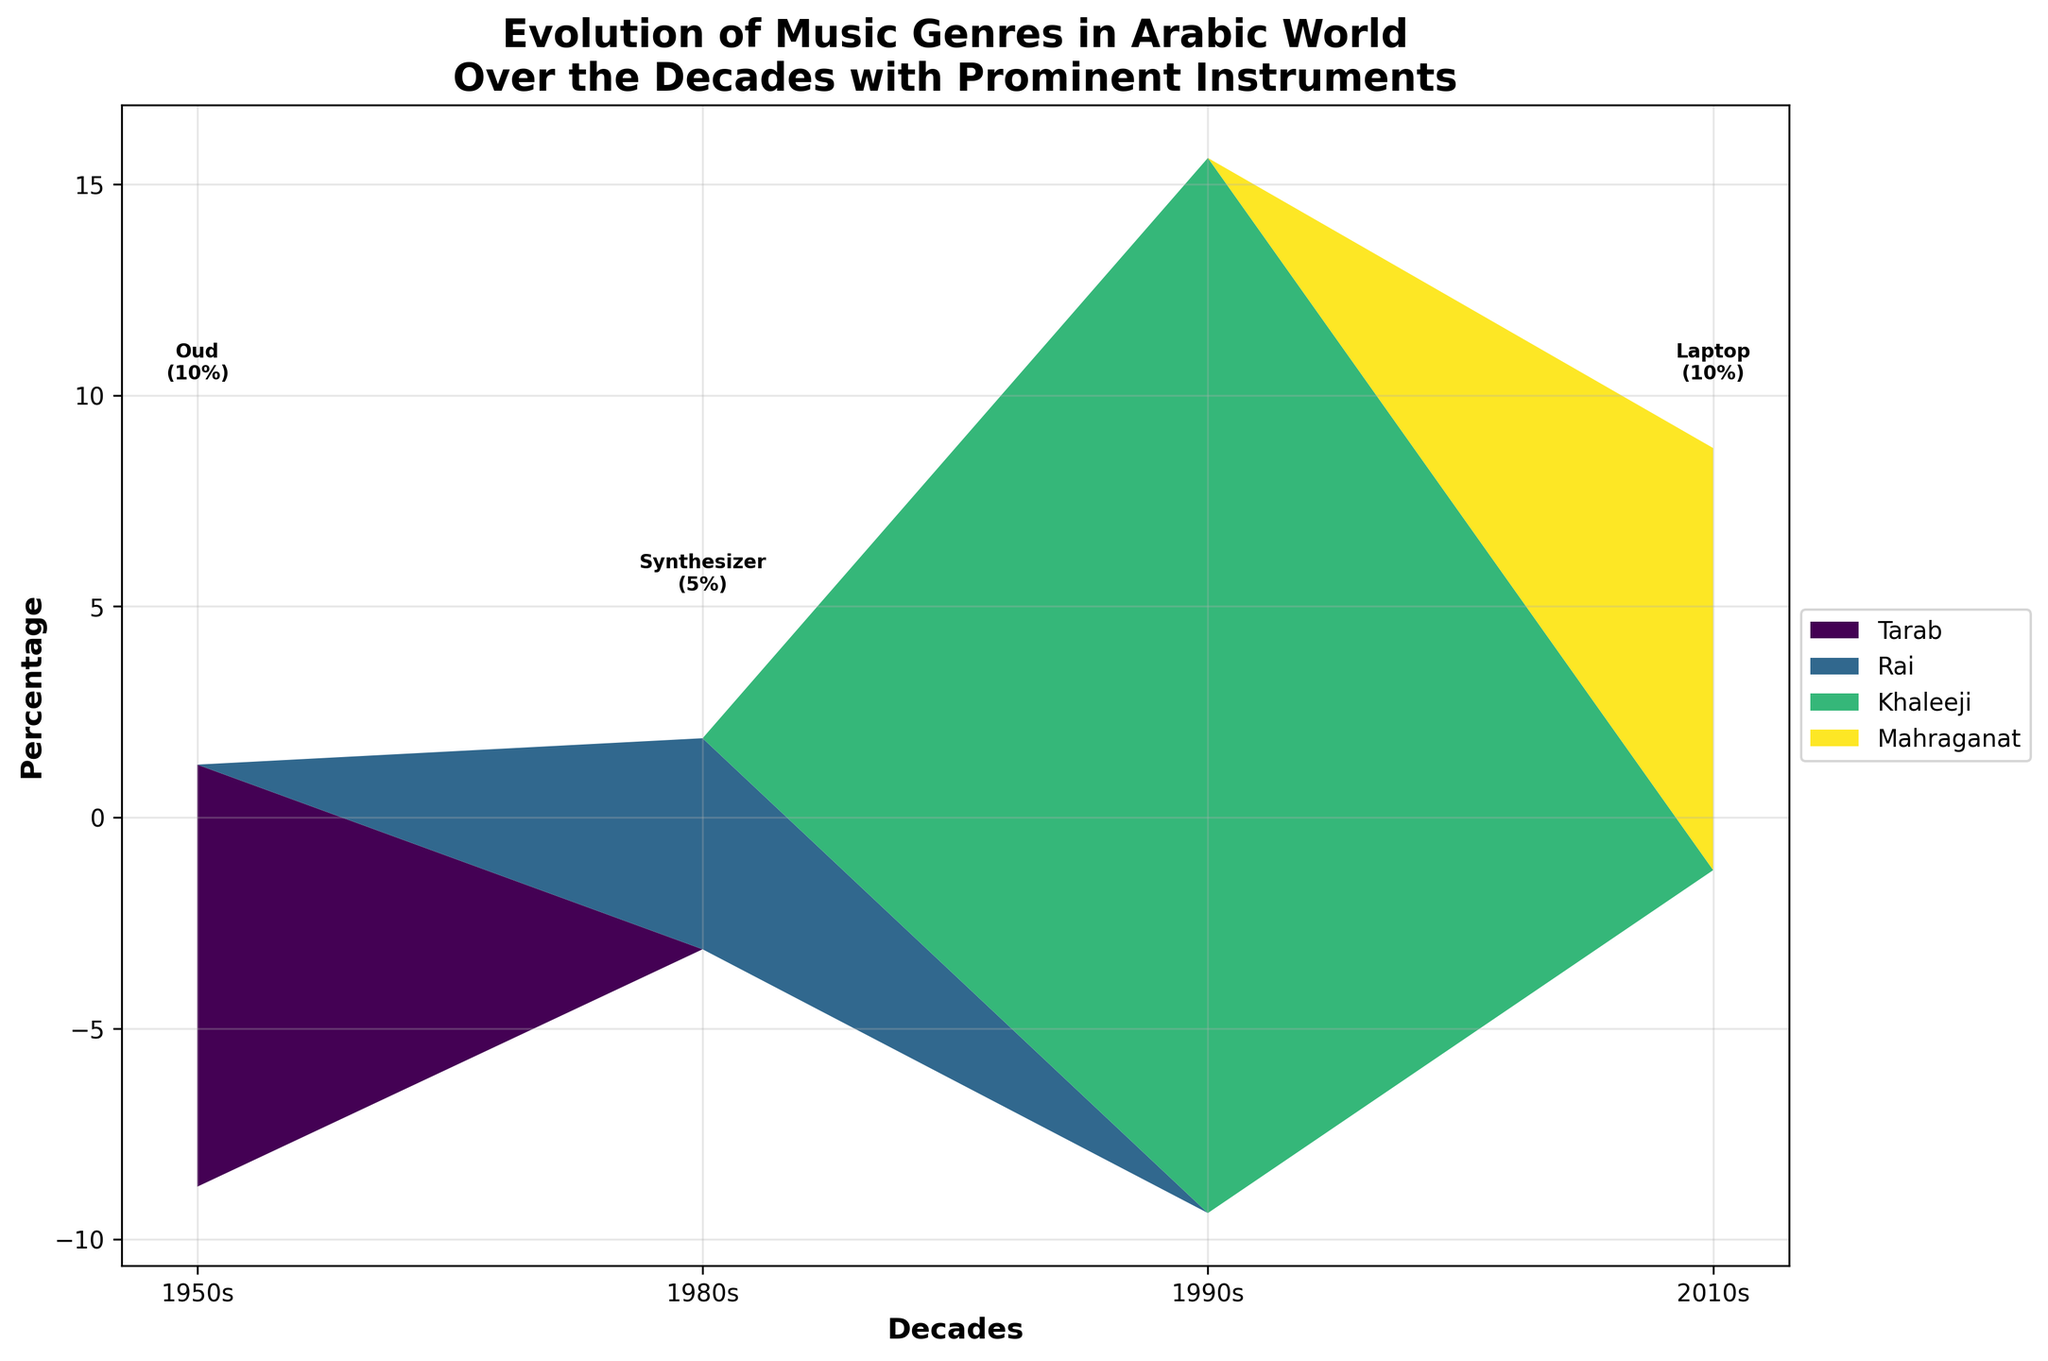What is the title of the figure? The title is usually found at the top of the figure, summarizing the content of the plot. In this case, the title is "Evolution of Music Genres in Arabic World Over the Decades with Prominent Instruments Highlighted".
Answer: Evolution of Music Genres in Arabic World Over the Decades with Prominent Instruments Highlighted Which decade has the highest percentage of electronic instruments? To find this, look for the decade with the predominant presence of synthesizers, drum machines, samplers, and laptops in the figure. The 2010s has the highest percentage due to Mahraganat genre featuring laptop and sampler with a combined percentage of 70%.
Answer: 2010s Which genre peaked in percentage in the 1980s, and what instrument was most prominent? Identify the genre with the highest area in the 1980s on the stream graph. Rai genre peaked in the 1980s, and the most prominent instrument was the synthesizer with 50%.
Answer: Rai, Synthesizer Compare the percentages of Oud in different decades. Look at the Oud percentages in the 1950s (Tarab - 40%) and the 1990s (Khaleeji - 35%) from the figure. The percentage of Oud in the 1950s is 40%, which is higher than in the 1990s with 35%.
Answer: 1950s: 40%, 1990s: 35% What is the most prominent genre in the 1950s and its leading instruments? Identify the genre with the highest area in the 1950s and its top instruments. The most prominent genre in the 1950s is Tarab, with Oud (40%) and Violin (30%) being the leading instruments.
Answer: Tarab, Oud and Violin How did Khaleeji's instrument mix change in the 1990s? Examine the instruments and their percentages in 1990s for Khaleeji: Oud (35%), Tabla (25%), Ney (25%), and Sitar (15%). Khaleeji exhibits a diverse mix, with Ney and Tabla playing significant roles.
Answer: Oud (35%), Tabla (25%), Ney (25%), Sitar (15%) Which genre emerged prominently in the 2010s, and what are the key instruments? Identify the genre that takes a significant portion in the 2010s, which is Mahraganat, featuring Laptop (40%), Sampler (30%), and Keyboard (20%) as key instruments.
Answer: Mahraganat, Laptop, Sampler, Keyboard Compare the total percentage of traditional vs electronic instruments in 2010s. Traditional instruments (Keyboard) count is 20%, and electronic instruments (Laptop, Sampler, Rap Vocals) add up to 80%. Thus, electronic instruments dominate with 80%.
Answer: Traditional: 20%, Electronic: 80% What do you notice about the percentage of the Oud over the decades? Observe the visual changes in areas representing the Oud from the 1950s (Tarab - 40%) to 1990s (Khaleeji - 35%). It declines slightly from 40% to 35%, indicating a reduction.
Answer: Decreased from 40% to 35% 